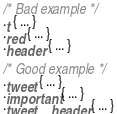Convert code to text. <code><loc_0><loc_0><loc_500><loc_500><_CSS_>/* Bad example */
.t { ... }
.red { ... }
.header { ... }

/* Good example */
.tweet { ... }
.important { ... }
.tweet__header { ... }
</code> 